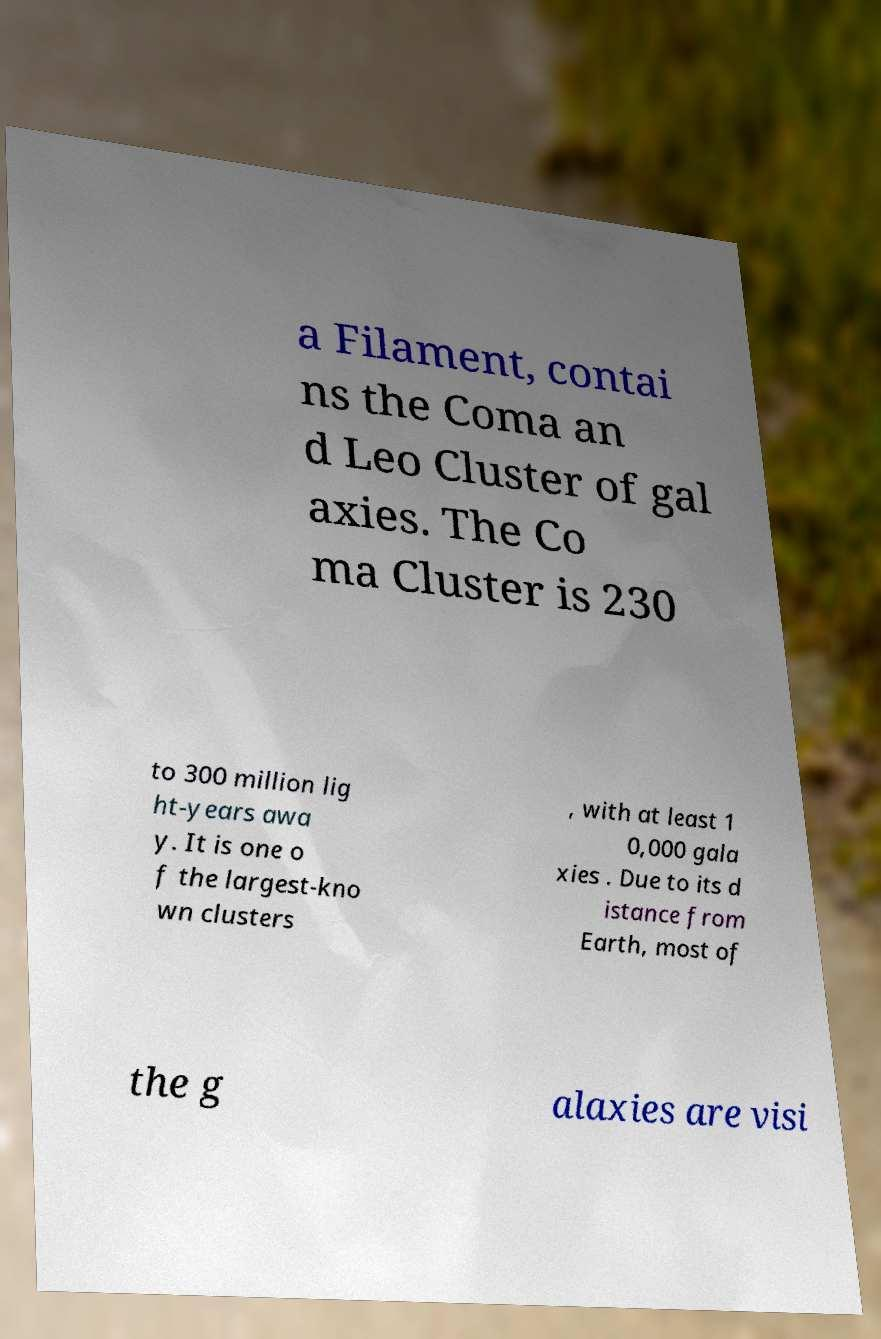What messages or text are displayed in this image? I need them in a readable, typed format. a Filament, contai ns the Coma an d Leo Cluster of gal axies. The Co ma Cluster is 230 to 300 million lig ht-years awa y. It is one o f the largest-kno wn clusters , with at least 1 0,000 gala xies . Due to its d istance from Earth, most of the g alaxies are visi 